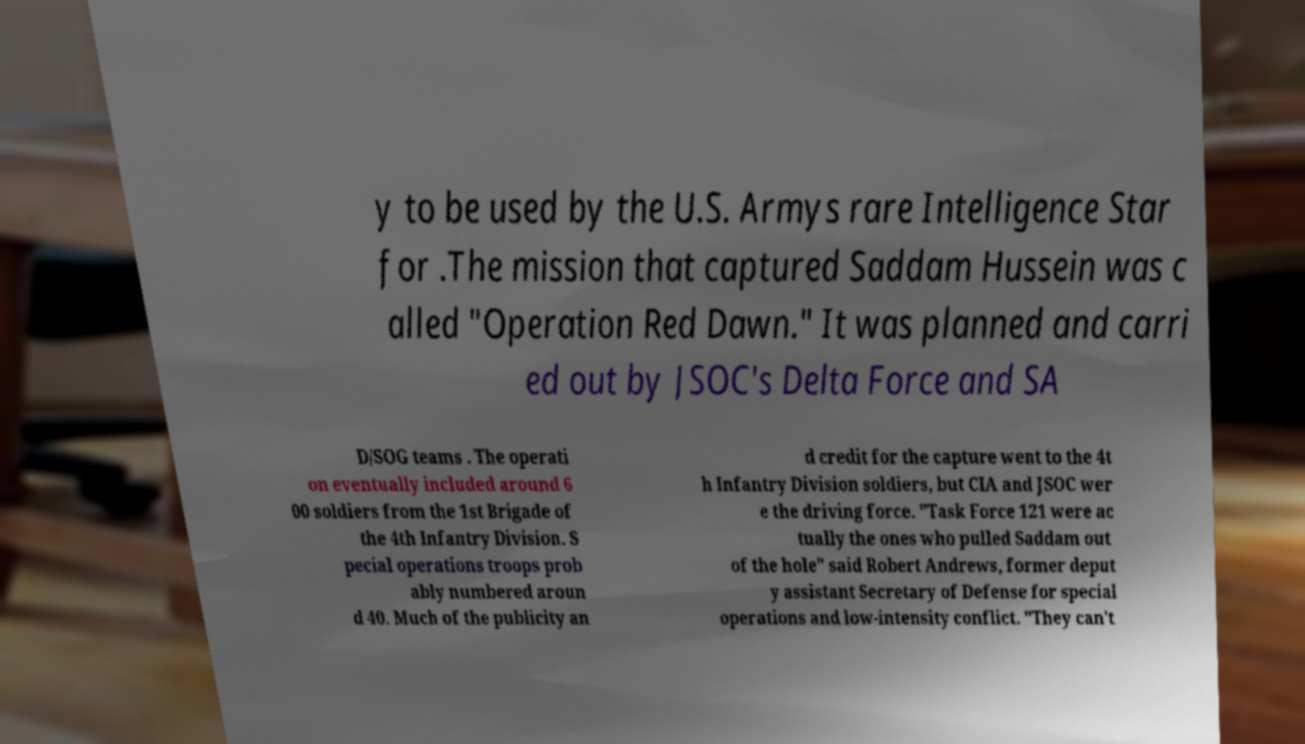Could you assist in decoding the text presented in this image and type it out clearly? y to be used by the U.S. Armys rare Intelligence Star for .The mission that captured Saddam Hussein was c alled "Operation Red Dawn." It was planned and carri ed out by JSOC's Delta Force and SA D/SOG teams . The operati on eventually included around 6 00 soldiers from the 1st Brigade of the 4th Infantry Division. S pecial operations troops prob ably numbered aroun d 40. Much of the publicity an d credit for the capture went to the 4t h Infantry Division soldiers, but CIA and JSOC wer e the driving force. "Task Force 121 were ac tually the ones who pulled Saddam out of the hole" said Robert Andrews, former deput y assistant Secretary of Defense for special operations and low-intensity conflict. "They can't 